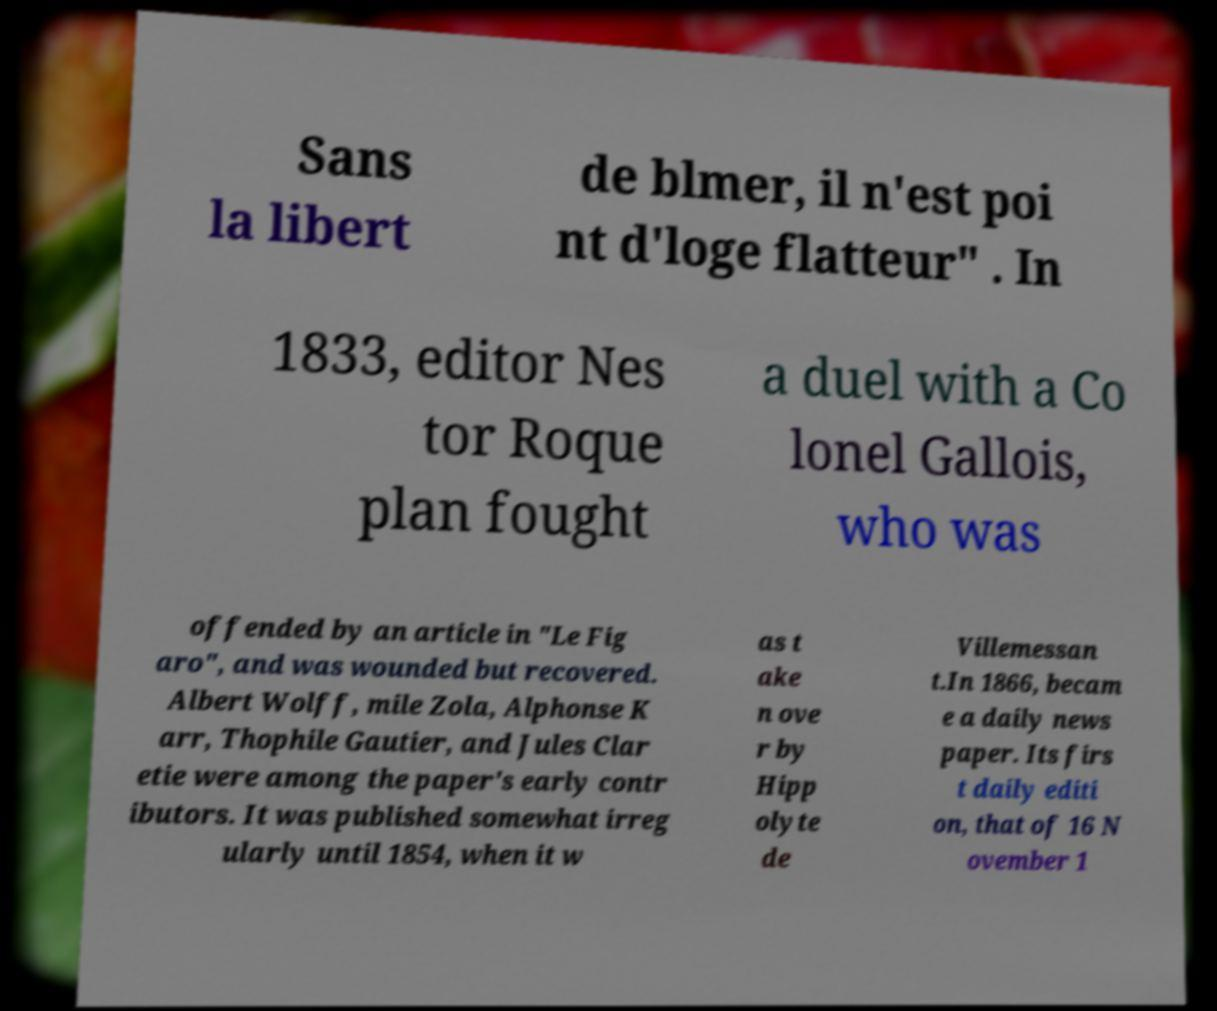Please identify and transcribe the text found in this image. Sans la libert de blmer, il n'est poi nt d'loge flatteur" . In 1833, editor Nes tor Roque plan fought a duel with a Co lonel Gallois, who was offended by an article in "Le Fig aro", and was wounded but recovered. Albert Wolff, mile Zola, Alphonse K arr, Thophile Gautier, and Jules Clar etie were among the paper's early contr ibutors. It was published somewhat irreg ularly until 1854, when it w as t ake n ove r by Hipp olyte de Villemessan t.In 1866, becam e a daily news paper. Its firs t daily editi on, that of 16 N ovember 1 